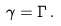Convert formula to latex. <formula><loc_0><loc_0><loc_500><loc_500>\gamma = \Gamma \, .</formula> 